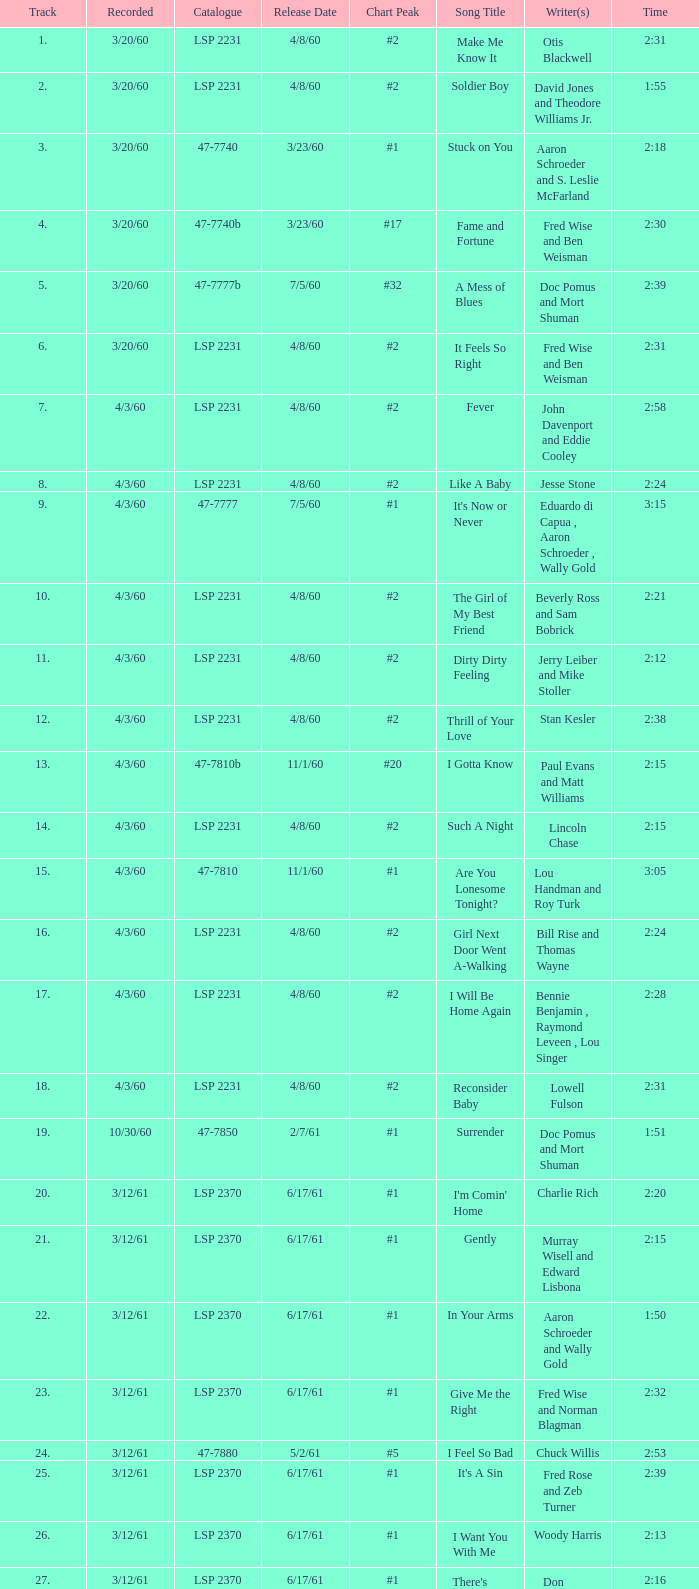On songs that have a release date of 6/17/61, a track larger than 20, and a writer of Woody Harris, what is the chart peak? #1. 